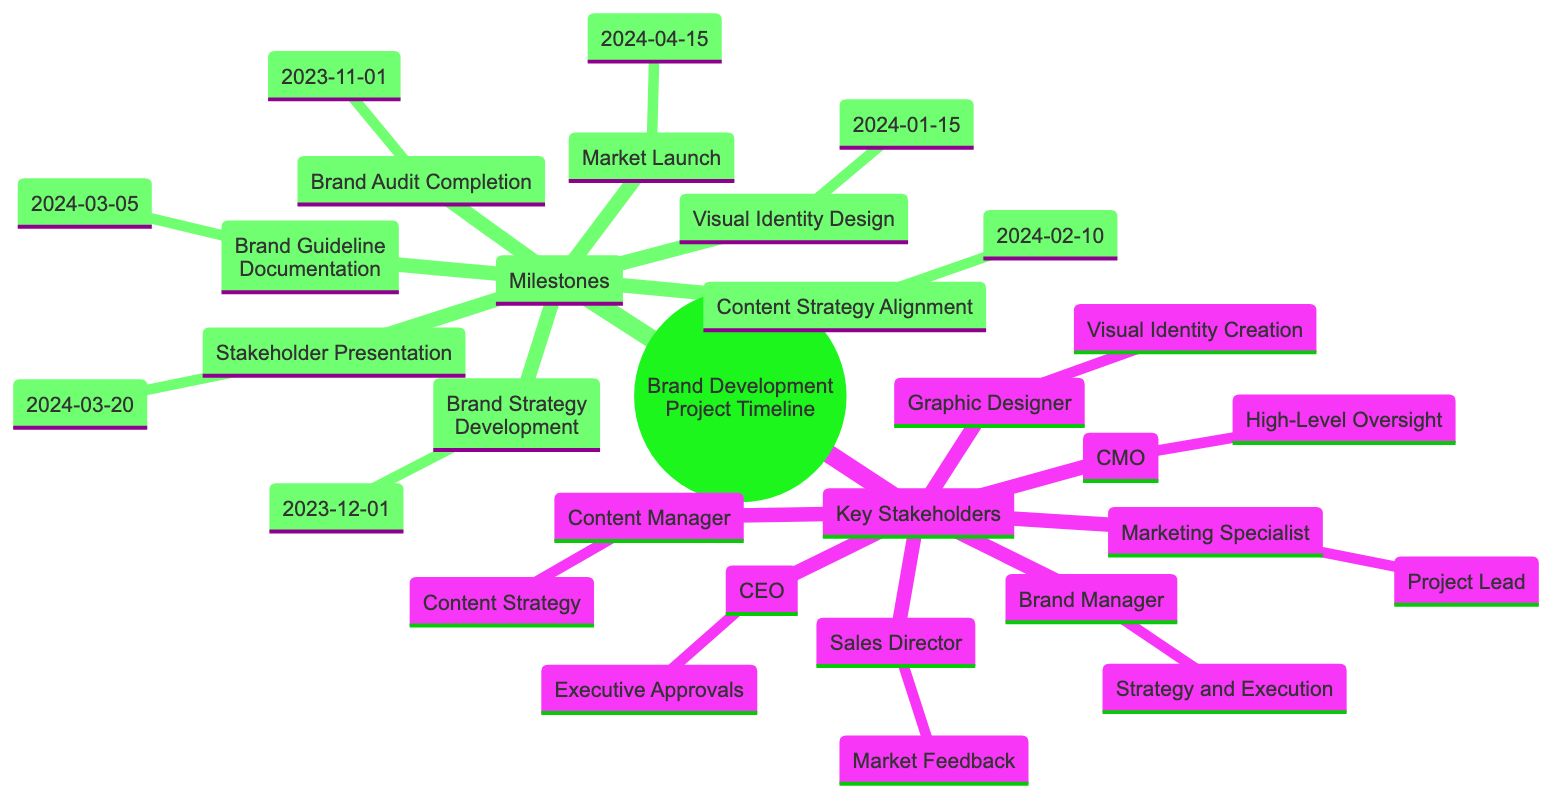What is the first milestone on the timeline? The first milestone in the provided timeline is "Brand Audit Completion," which is scheduled for November 1, 2023.
Answer: Brand Audit Completion How many key stakeholders are involved in the brand development project? The diagram lists seven key stakeholders associated with the project. By counting the names under the "Key Stakeholders" section, we find seven distinct roles.
Answer: 7 What is the date for the "Market Launch"? The "Market Launch" milestone is set for April 15, 2024, as indicated in the timeline section of the diagram.
Answer: 2024-04-15 Which role is responsible for visual identity creation? The "Graphic Designer" is responsible for visual identity creation, as listed under the "Key Stakeholders."
Answer: Graphic Designer What milestone follows "Brand Strategy Development"? Following the "Brand Strategy Development," which occurs on December 1, 2023, the next milestone is "Visual Identity Design" scheduled for January 15, 2024.
Answer: Visual Identity Design Who needs to provide final approval on key milestones? The "CEO" is the individual who provides final approvals on key milestones and strategies, as per the responsibilities outlined in the "Key Stakeholders" section.
Answer: CEO Which milestone requires content strategy alignment? The milestone that requires content strategy alignment is "Content Strategy Alignment," which takes place on February 10, 2024, as shown in the timeline.
Answer: Content Strategy Alignment What is the role of the Sales Director? The "Sales Director" serves the role of providing market feedback, which is clearly stated in the responsibilities for key stakeholders.
Answer: Market Feedback What document is created on March 5, 2024? On March 5, 2024, the "Brand Guideline Documentation" is created to ensure consistent usage of the brand elements.
Answer: Brand Guideline Documentation 